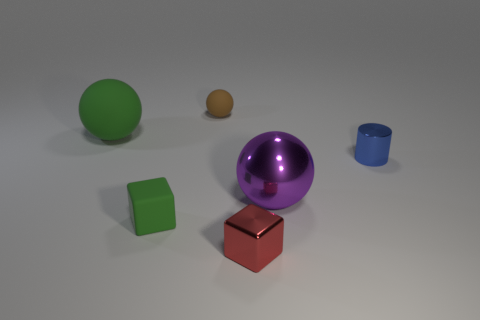Add 1 tiny red spheres. How many objects exist? 7 Subtract all cylinders. How many objects are left? 5 Subtract all big blue metallic cylinders. Subtract all cylinders. How many objects are left? 5 Add 5 small blue objects. How many small blue objects are left? 6 Add 4 blue cylinders. How many blue cylinders exist? 5 Subtract 0 blue cubes. How many objects are left? 6 